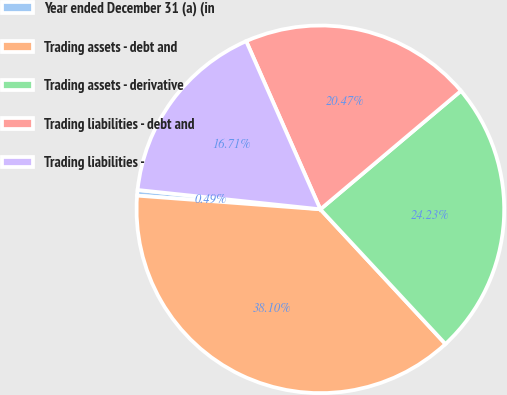<chart> <loc_0><loc_0><loc_500><loc_500><pie_chart><fcel>Year ended December 31 (a) (in<fcel>Trading assets - debt and<fcel>Trading assets - derivative<fcel>Trading liabilities - debt and<fcel>Trading liabilities -<nl><fcel>0.49%<fcel>38.1%<fcel>24.23%<fcel>20.47%<fcel>16.71%<nl></chart> 